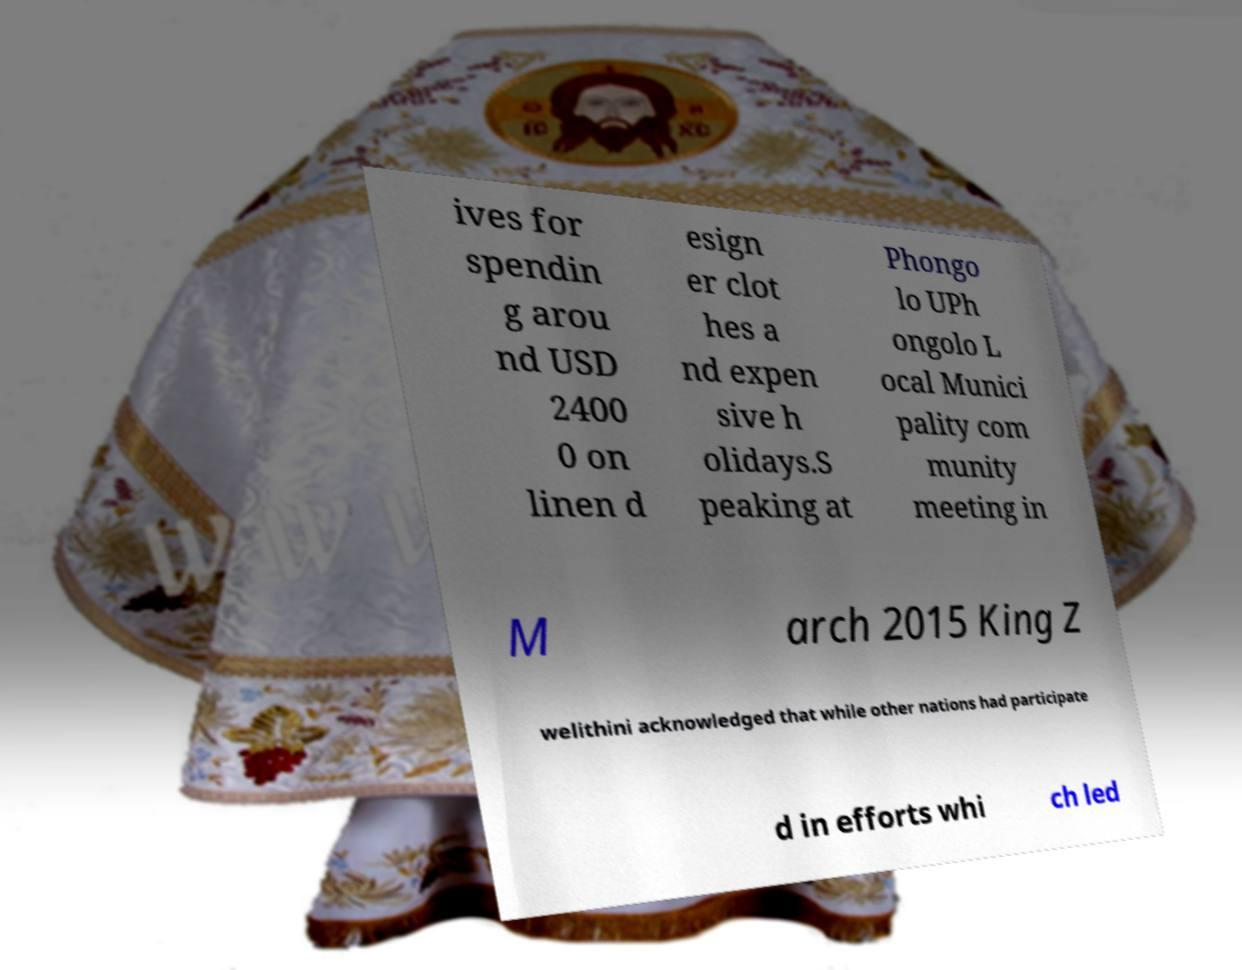For documentation purposes, I need the text within this image transcribed. Could you provide that? ives for spendin g arou nd USD 2400 0 on linen d esign er clot hes a nd expen sive h olidays.S peaking at Phongo lo UPh ongolo L ocal Munici pality com munity meeting in M arch 2015 King Z welithini acknowledged that while other nations had participate d in efforts whi ch led 